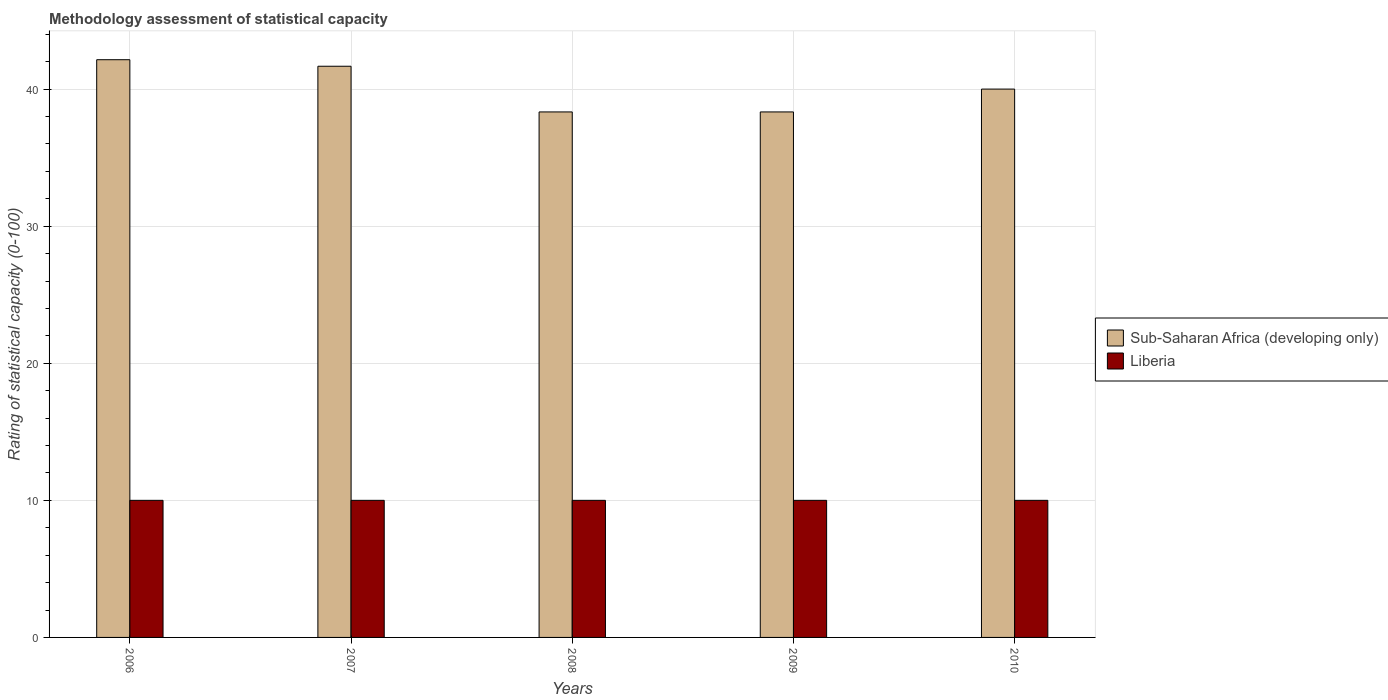How many different coloured bars are there?
Your answer should be very brief. 2. Are the number of bars per tick equal to the number of legend labels?
Provide a succinct answer. Yes. How many bars are there on the 4th tick from the left?
Provide a short and direct response. 2. How many bars are there on the 2nd tick from the right?
Your answer should be very brief. 2. In how many cases, is the number of bars for a given year not equal to the number of legend labels?
Ensure brevity in your answer.  0. What is the rating of statistical capacity in Sub-Saharan Africa (developing only) in 2007?
Your answer should be compact. 41.67. Across all years, what is the maximum rating of statistical capacity in Sub-Saharan Africa (developing only)?
Provide a short and direct response. 42.14. Across all years, what is the minimum rating of statistical capacity in Liberia?
Make the answer very short. 10. What is the total rating of statistical capacity in Liberia in the graph?
Give a very brief answer. 50. What is the difference between the rating of statistical capacity in Liberia in 2006 and that in 2009?
Make the answer very short. 0. What is the difference between the rating of statistical capacity in Liberia in 2008 and the rating of statistical capacity in Sub-Saharan Africa (developing only) in 2009?
Offer a very short reply. -28.33. What is the average rating of statistical capacity in Sub-Saharan Africa (developing only) per year?
Give a very brief answer. 40.1. In the year 2008, what is the difference between the rating of statistical capacity in Sub-Saharan Africa (developing only) and rating of statistical capacity in Liberia?
Provide a succinct answer. 28.33. Is the difference between the rating of statistical capacity in Sub-Saharan Africa (developing only) in 2008 and 2009 greater than the difference between the rating of statistical capacity in Liberia in 2008 and 2009?
Your answer should be compact. No. What is the difference between the highest and the lowest rating of statistical capacity in Sub-Saharan Africa (developing only)?
Ensure brevity in your answer.  3.81. In how many years, is the rating of statistical capacity in Sub-Saharan Africa (developing only) greater than the average rating of statistical capacity in Sub-Saharan Africa (developing only) taken over all years?
Your answer should be compact. 2. What does the 2nd bar from the left in 2006 represents?
Your answer should be compact. Liberia. What does the 1st bar from the right in 2010 represents?
Make the answer very short. Liberia. How many bars are there?
Provide a short and direct response. 10. Are all the bars in the graph horizontal?
Keep it short and to the point. No. Are the values on the major ticks of Y-axis written in scientific E-notation?
Offer a terse response. No. Does the graph contain any zero values?
Provide a succinct answer. No. Does the graph contain grids?
Offer a terse response. Yes. Where does the legend appear in the graph?
Ensure brevity in your answer.  Center right. How are the legend labels stacked?
Ensure brevity in your answer.  Vertical. What is the title of the graph?
Keep it short and to the point. Methodology assessment of statistical capacity. What is the label or title of the Y-axis?
Offer a very short reply. Rating of statistical capacity (0-100). What is the Rating of statistical capacity (0-100) of Sub-Saharan Africa (developing only) in 2006?
Provide a short and direct response. 42.14. What is the Rating of statistical capacity (0-100) in Sub-Saharan Africa (developing only) in 2007?
Keep it short and to the point. 41.67. What is the Rating of statistical capacity (0-100) in Liberia in 2007?
Your answer should be compact. 10. What is the Rating of statistical capacity (0-100) of Sub-Saharan Africa (developing only) in 2008?
Provide a succinct answer. 38.33. What is the Rating of statistical capacity (0-100) of Sub-Saharan Africa (developing only) in 2009?
Keep it short and to the point. 38.33. What is the Rating of statistical capacity (0-100) in Liberia in 2010?
Offer a terse response. 10. Across all years, what is the maximum Rating of statistical capacity (0-100) in Sub-Saharan Africa (developing only)?
Give a very brief answer. 42.14. Across all years, what is the minimum Rating of statistical capacity (0-100) in Sub-Saharan Africa (developing only)?
Keep it short and to the point. 38.33. Across all years, what is the minimum Rating of statistical capacity (0-100) in Liberia?
Make the answer very short. 10. What is the total Rating of statistical capacity (0-100) in Sub-Saharan Africa (developing only) in the graph?
Provide a short and direct response. 200.48. What is the difference between the Rating of statistical capacity (0-100) of Sub-Saharan Africa (developing only) in 2006 and that in 2007?
Give a very brief answer. 0.48. What is the difference between the Rating of statistical capacity (0-100) in Liberia in 2006 and that in 2007?
Your answer should be very brief. 0. What is the difference between the Rating of statistical capacity (0-100) of Sub-Saharan Africa (developing only) in 2006 and that in 2008?
Your response must be concise. 3.81. What is the difference between the Rating of statistical capacity (0-100) of Liberia in 2006 and that in 2008?
Your response must be concise. 0. What is the difference between the Rating of statistical capacity (0-100) in Sub-Saharan Africa (developing only) in 2006 and that in 2009?
Give a very brief answer. 3.81. What is the difference between the Rating of statistical capacity (0-100) of Sub-Saharan Africa (developing only) in 2006 and that in 2010?
Your answer should be very brief. 2.14. What is the difference between the Rating of statistical capacity (0-100) of Liberia in 2006 and that in 2010?
Offer a very short reply. 0. What is the difference between the Rating of statistical capacity (0-100) in Liberia in 2007 and that in 2008?
Your answer should be compact. 0. What is the difference between the Rating of statistical capacity (0-100) in Liberia in 2007 and that in 2009?
Provide a short and direct response. 0. What is the difference between the Rating of statistical capacity (0-100) in Liberia in 2007 and that in 2010?
Keep it short and to the point. 0. What is the difference between the Rating of statistical capacity (0-100) of Sub-Saharan Africa (developing only) in 2008 and that in 2009?
Offer a terse response. 0. What is the difference between the Rating of statistical capacity (0-100) of Sub-Saharan Africa (developing only) in 2008 and that in 2010?
Make the answer very short. -1.67. What is the difference between the Rating of statistical capacity (0-100) in Sub-Saharan Africa (developing only) in 2009 and that in 2010?
Your response must be concise. -1.67. What is the difference between the Rating of statistical capacity (0-100) of Liberia in 2009 and that in 2010?
Your response must be concise. 0. What is the difference between the Rating of statistical capacity (0-100) in Sub-Saharan Africa (developing only) in 2006 and the Rating of statistical capacity (0-100) in Liberia in 2007?
Ensure brevity in your answer.  32.14. What is the difference between the Rating of statistical capacity (0-100) of Sub-Saharan Africa (developing only) in 2006 and the Rating of statistical capacity (0-100) of Liberia in 2008?
Provide a short and direct response. 32.14. What is the difference between the Rating of statistical capacity (0-100) in Sub-Saharan Africa (developing only) in 2006 and the Rating of statistical capacity (0-100) in Liberia in 2009?
Your answer should be compact. 32.14. What is the difference between the Rating of statistical capacity (0-100) of Sub-Saharan Africa (developing only) in 2006 and the Rating of statistical capacity (0-100) of Liberia in 2010?
Give a very brief answer. 32.14. What is the difference between the Rating of statistical capacity (0-100) of Sub-Saharan Africa (developing only) in 2007 and the Rating of statistical capacity (0-100) of Liberia in 2008?
Offer a terse response. 31.67. What is the difference between the Rating of statistical capacity (0-100) in Sub-Saharan Africa (developing only) in 2007 and the Rating of statistical capacity (0-100) in Liberia in 2009?
Offer a terse response. 31.67. What is the difference between the Rating of statistical capacity (0-100) of Sub-Saharan Africa (developing only) in 2007 and the Rating of statistical capacity (0-100) of Liberia in 2010?
Make the answer very short. 31.67. What is the difference between the Rating of statistical capacity (0-100) in Sub-Saharan Africa (developing only) in 2008 and the Rating of statistical capacity (0-100) in Liberia in 2009?
Your answer should be very brief. 28.33. What is the difference between the Rating of statistical capacity (0-100) of Sub-Saharan Africa (developing only) in 2008 and the Rating of statistical capacity (0-100) of Liberia in 2010?
Your answer should be compact. 28.33. What is the difference between the Rating of statistical capacity (0-100) in Sub-Saharan Africa (developing only) in 2009 and the Rating of statistical capacity (0-100) in Liberia in 2010?
Offer a terse response. 28.33. What is the average Rating of statistical capacity (0-100) of Sub-Saharan Africa (developing only) per year?
Provide a succinct answer. 40.1. In the year 2006, what is the difference between the Rating of statistical capacity (0-100) in Sub-Saharan Africa (developing only) and Rating of statistical capacity (0-100) in Liberia?
Keep it short and to the point. 32.14. In the year 2007, what is the difference between the Rating of statistical capacity (0-100) in Sub-Saharan Africa (developing only) and Rating of statistical capacity (0-100) in Liberia?
Offer a very short reply. 31.67. In the year 2008, what is the difference between the Rating of statistical capacity (0-100) in Sub-Saharan Africa (developing only) and Rating of statistical capacity (0-100) in Liberia?
Make the answer very short. 28.33. In the year 2009, what is the difference between the Rating of statistical capacity (0-100) of Sub-Saharan Africa (developing only) and Rating of statistical capacity (0-100) of Liberia?
Your response must be concise. 28.33. What is the ratio of the Rating of statistical capacity (0-100) in Sub-Saharan Africa (developing only) in 2006 to that in 2007?
Ensure brevity in your answer.  1.01. What is the ratio of the Rating of statistical capacity (0-100) in Sub-Saharan Africa (developing only) in 2006 to that in 2008?
Give a very brief answer. 1.1. What is the ratio of the Rating of statistical capacity (0-100) of Sub-Saharan Africa (developing only) in 2006 to that in 2009?
Provide a succinct answer. 1.1. What is the ratio of the Rating of statistical capacity (0-100) of Liberia in 2006 to that in 2009?
Offer a terse response. 1. What is the ratio of the Rating of statistical capacity (0-100) of Sub-Saharan Africa (developing only) in 2006 to that in 2010?
Ensure brevity in your answer.  1.05. What is the ratio of the Rating of statistical capacity (0-100) in Liberia in 2006 to that in 2010?
Make the answer very short. 1. What is the ratio of the Rating of statistical capacity (0-100) in Sub-Saharan Africa (developing only) in 2007 to that in 2008?
Keep it short and to the point. 1.09. What is the ratio of the Rating of statistical capacity (0-100) in Liberia in 2007 to that in 2008?
Your answer should be compact. 1. What is the ratio of the Rating of statistical capacity (0-100) of Sub-Saharan Africa (developing only) in 2007 to that in 2009?
Give a very brief answer. 1.09. What is the ratio of the Rating of statistical capacity (0-100) of Sub-Saharan Africa (developing only) in 2007 to that in 2010?
Provide a succinct answer. 1.04. What is the ratio of the Rating of statistical capacity (0-100) in Sub-Saharan Africa (developing only) in 2008 to that in 2009?
Your answer should be very brief. 1. What is the ratio of the Rating of statistical capacity (0-100) in Liberia in 2008 to that in 2009?
Your answer should be very brief. 1. What is the ratio of the Rating of statistical capacity (0-100) in Sub-Saharan Africa (developing only) in 2008 to that in 2010?
Offer a very short reply. 0.96. What is the ratio of the Rating of statistical capacity (0-100) of Liberia in 2008 to that in 2010?
Offer a terse response. 1. What is the ratio of the Rating of statistical capacity (0-100) of Sub-Saharan Africa (developing only) in 2009 to that in 2010?
Give a very brief answer. 0.96. What is the difference between the highest and the second highest Rating of statistical capacity (0-100) in Sub-Saharan Africa (developing only)?
Offer a terse response. 0.48. What is the difference between the highest and the second highest Rating of statistical capacity (0-100) of Liberia?
Keep it short and to the point. 0. What is the difference between the highest and the lowest Rating of statistical capacity (0-100) of Sub-Saharan Africa (developing only)?
Provide a succinct answer. 3.81. What is the difference between the highest and the lowest Rating of statistical capacity (0-100) in Liberia?
Make the answer very short. 0. 